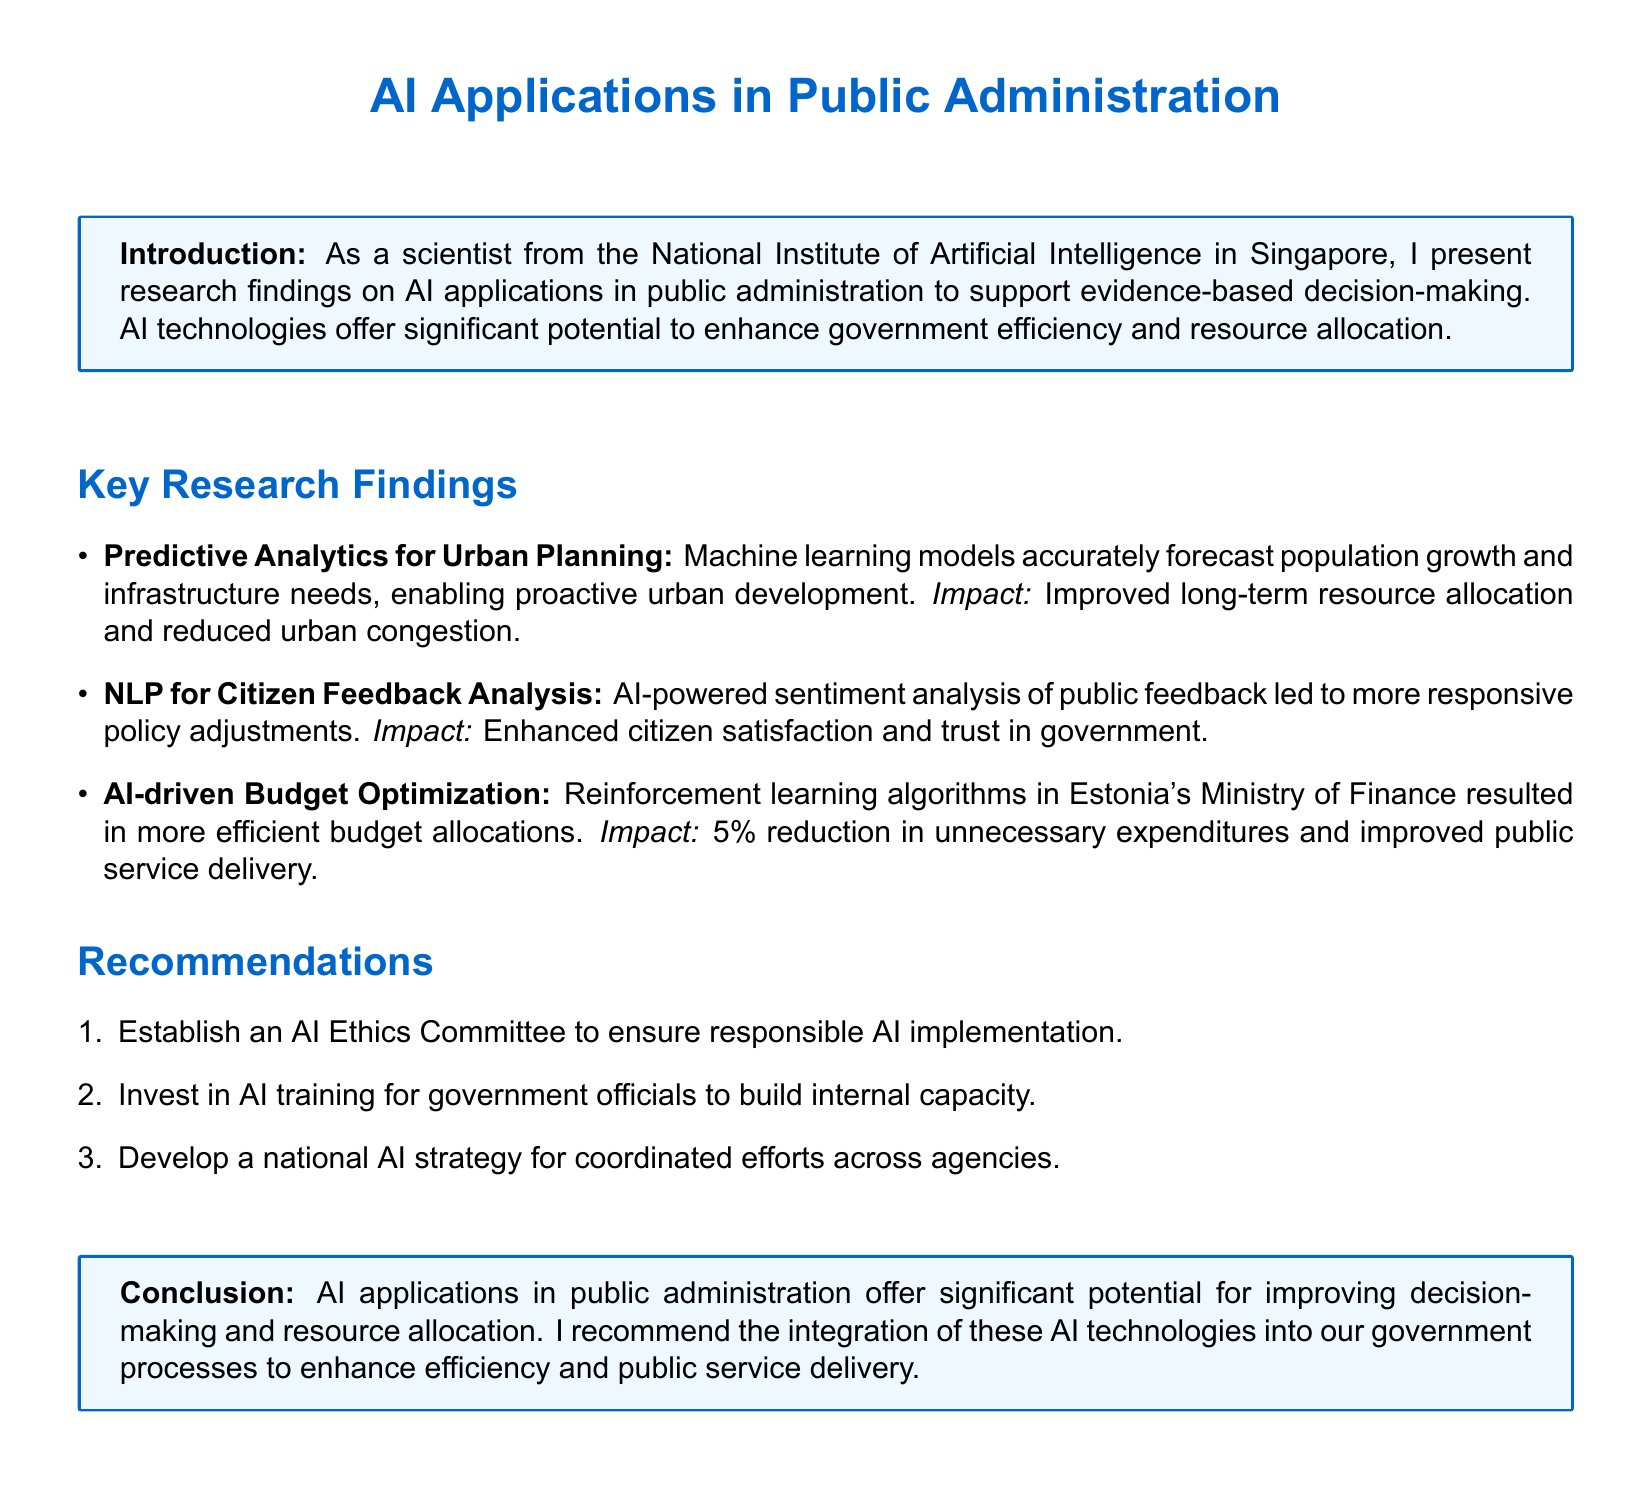What is the main focus of the document? The main focus of the document is described in the introduction, which emphasizes AI applications in public administration.
Answer: AI applications in public administration What methodology is mentioned for urban planning? The document mentions machine learning models as the methodology used for urban planning to forecast needs.
Answer: Machine learning models What impact did the NLP analysis have on citizen feedback? The document states that NLP for Citizen Feedback Analysis enhanced citizen satisfaction and trust in government.
Answer: Enhanced citizen satisfaction and trust What percentage reduction in unnecessary expenditures was achieved in Estonia? The document highlights a 5% reduction in unnecessary expenditures resulting from AI-driven budget optimization.
Answer: 5% What recommendation involves AI training? The document includes a recommendation to invest in AI training for government officials to build internal capacity.
Answer: Invest in AI training What is one benefit of AI-driven predictive analytics mentioned? The benefit of predictive analytics mentioned in the document is improved long-term resource allocation.
Answer: Improved long-term resource allocation How many main key research findings are listed? The document lists three key research findings regarding AI applications in public administration.
Answer: Three What does the conclusion suggest regarding AI integration? The conclusion recommends the integration of AI technologies into government processes.
Answer: Integration of AI technologies 